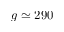<formula> <loc_0><loc_0><loc_500><loc_500>g \simeq 2 9 0</formula> 